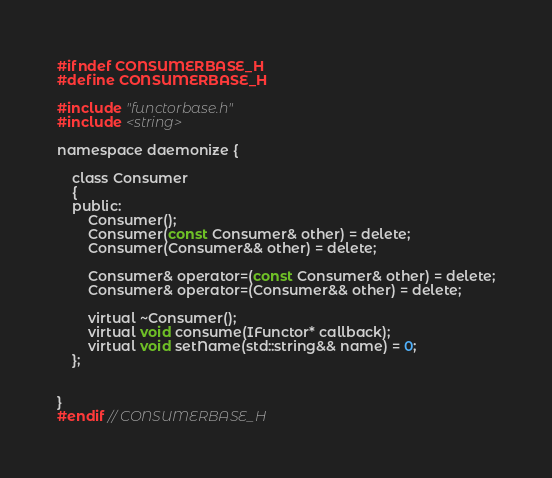Convert code to text. <code><loc_0><loc_0><loc_500><loc_500><_C_>#ifndef CONSUMERBASE_H
#define CONSUMERBASE_H

#include "functorbase.h"
#include <string>

namespace daemonize {

    class Consumer
    {
    public:
        Consumer();
        Consumer(const Consumer& other) = delete;
        Consumer(Consumer&& other) = delete;

        Consumer& operator=(const Consumer& other) = delete;
        Consumer& operator=(Consumer&& other) = delete;

        virtual ~Consumer();
        virtual void consume(IFunctor* callback);
        virtual void setName(std::string&& name) = 0;
    };


}
#endif // CONSUMERBASE_H
</code> 